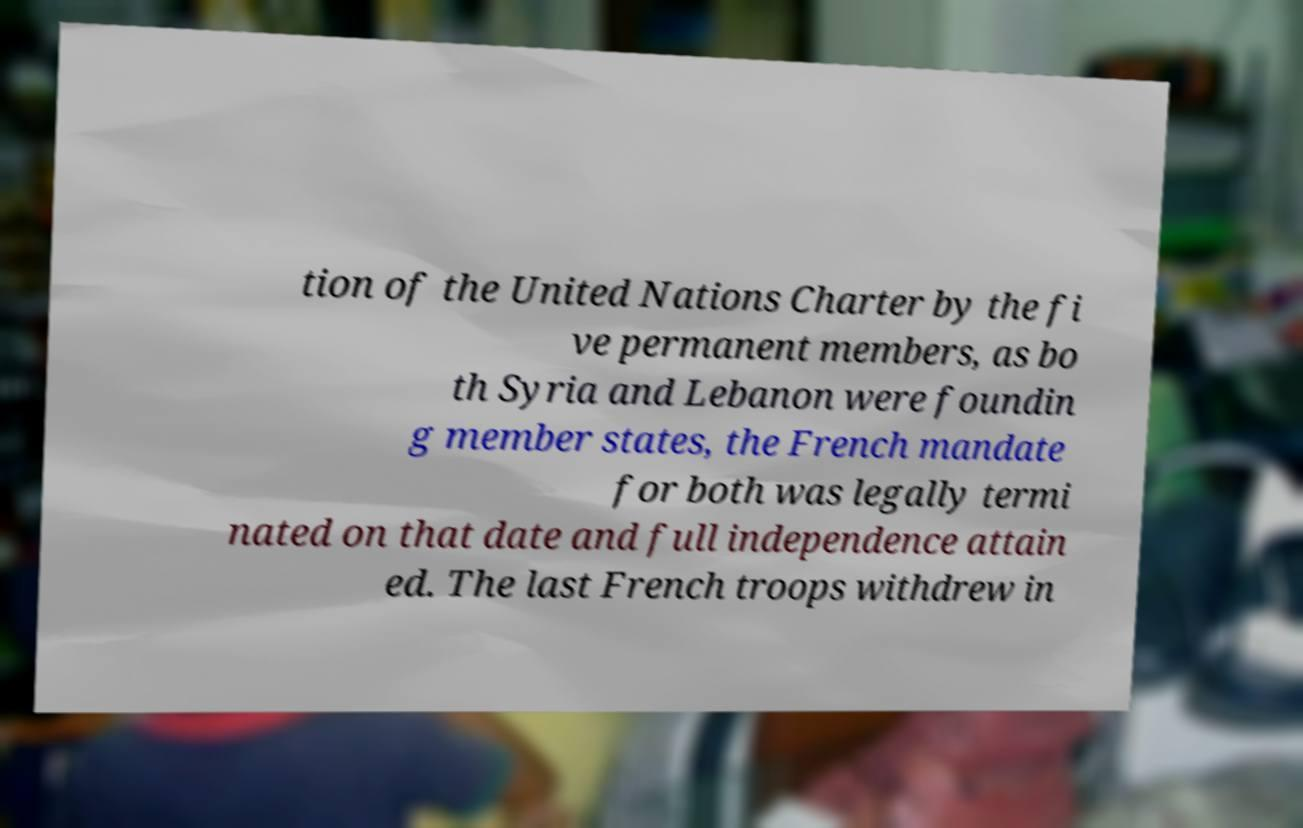Please read and relay the text visible in this image. What does it say? tion of the United Nations Charter by the fi ve permanent members, as bo th Syria and Lebanon were foundin g member states, the French mandate for both was legally termi nated on that date and full independence attain ed. The last French troops withdrew in 